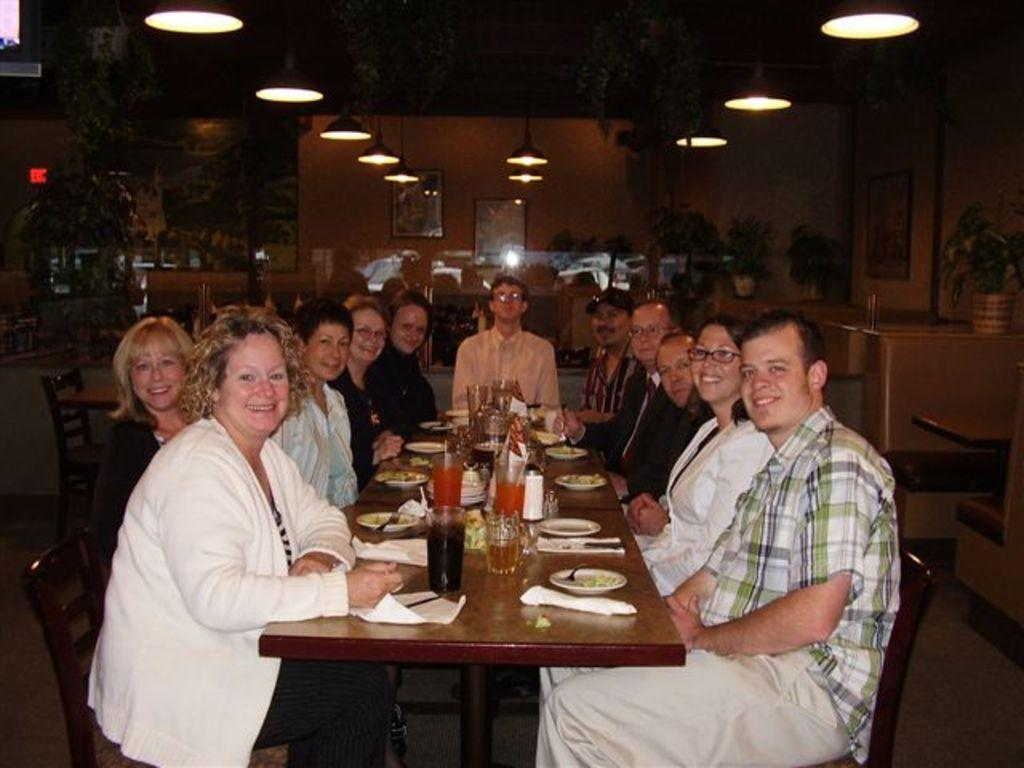What is happening in the image? There is a group of people in the image, and they are sitting around a table. What are the people doing while sitting around the table? The people are having food. What type of word can be seen on the table in the image? There is no word visible on the table in the image. 